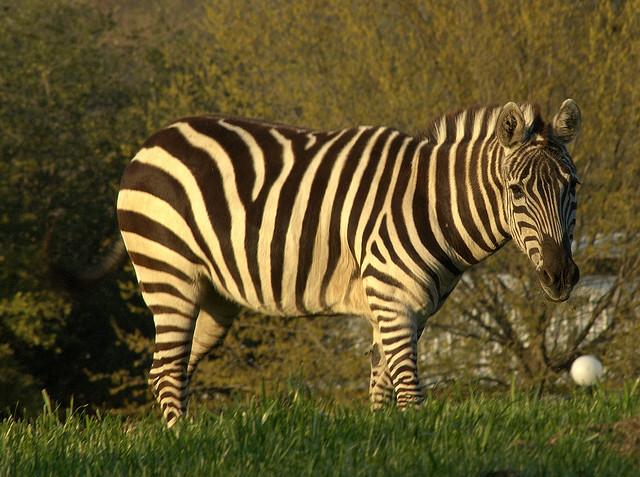Where was picture taken of the zebra?
Be succinct. Outside. How many stripes on each zebra?
Write a very short answer. 50. What color are the animals stripes?
Keep it brief. Black. How many zebras are in the photo?
Give a very brief answer. 1. Can you count how many strips it has?
Write a very short answer. Yes. How much dust is around the zebra?
Quick response, please. None. How many stripes are there?
Concise answer only. 100. What are the two colors on the zebra?
Give a very brief answer. Black and white. Does this animal look sick?
Keep it brief. No. Was this photo taken in the wild?
Give a very brief answer. Yes. Is this zebra looking for its colt?
Be succinct. No. Is this zebra in the wild?
Short answer required. Yes. What is the zebra doing?
Write a very short answer. Standing. 